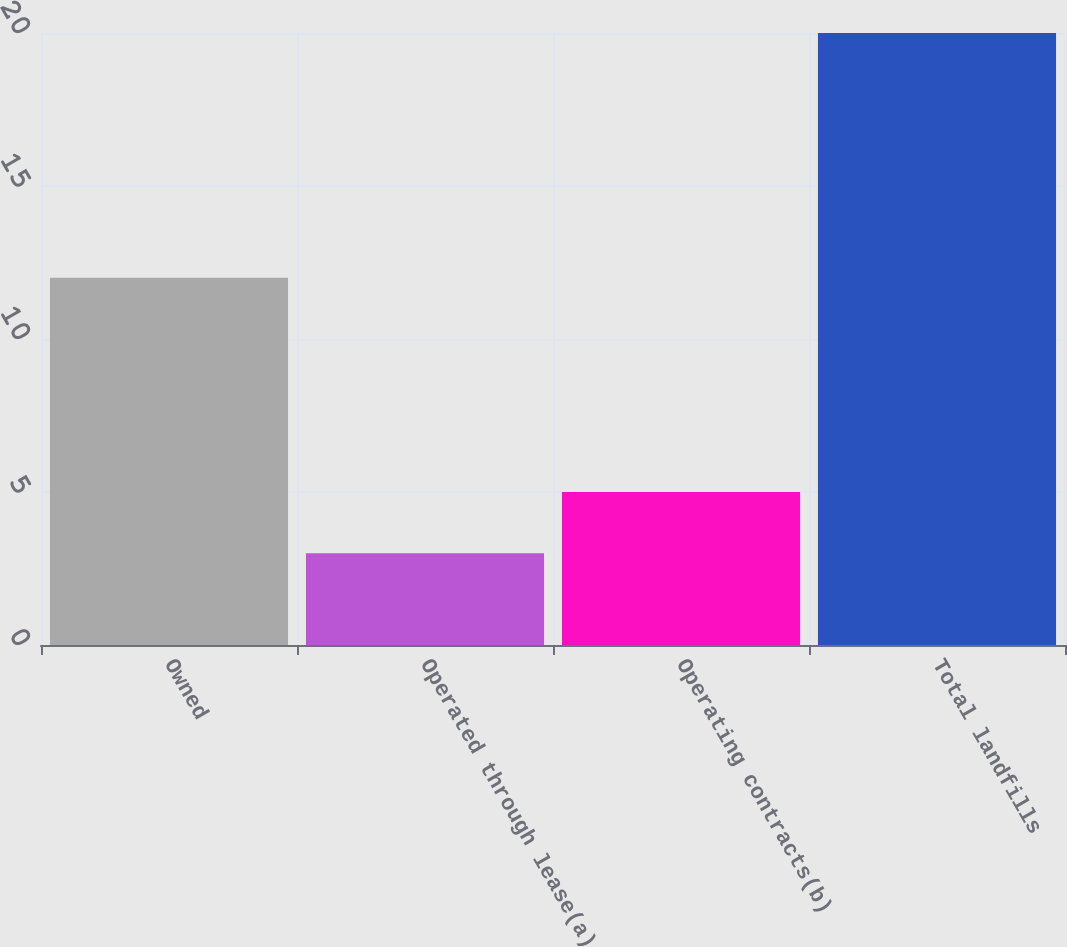Convert chart. <chart><loc_0><loc_0><loc_500><loc_500><bar_chart><fcel>Owned<fcel>Operated through lease(a)<fcel>Operating contracts(b)<fcel>Total landfills<nl><fcel>12<fcel>3<fcel>5<fcel>20<nl></chart> 